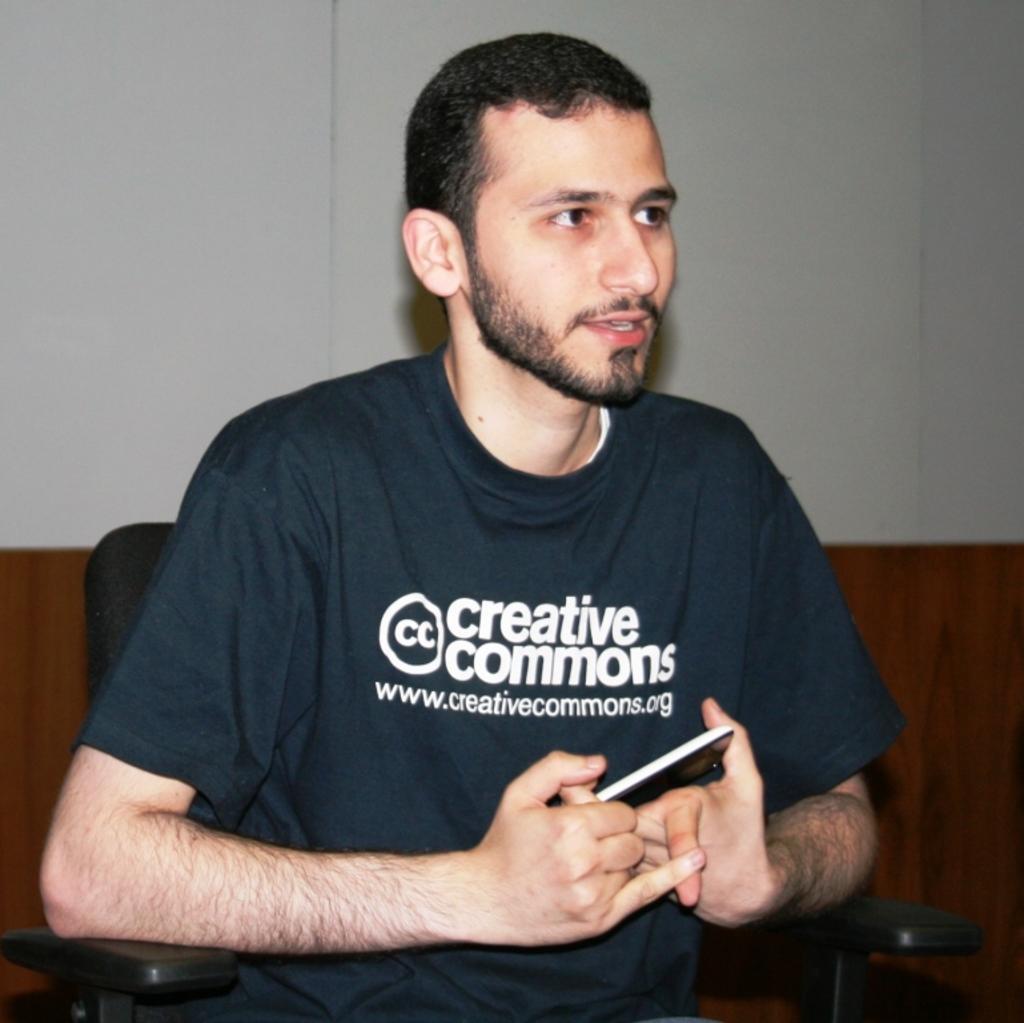Could you give a brief overview of what you see in this image? In this picture we can see man holding phone in his hand and talking and in background we can see wall. 